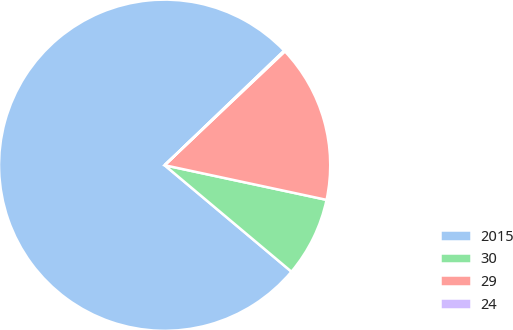Convert chart to OTSL. <chart><loc_0><loc_0><loc_500><loc_500><pie_chart><fcel>2015<fcel>30<fcel>29<fcel>24<nl><fcel>76.72%<fcel>7.76%<fcel>15.42%<fcel>0.1%<nl></chart> 